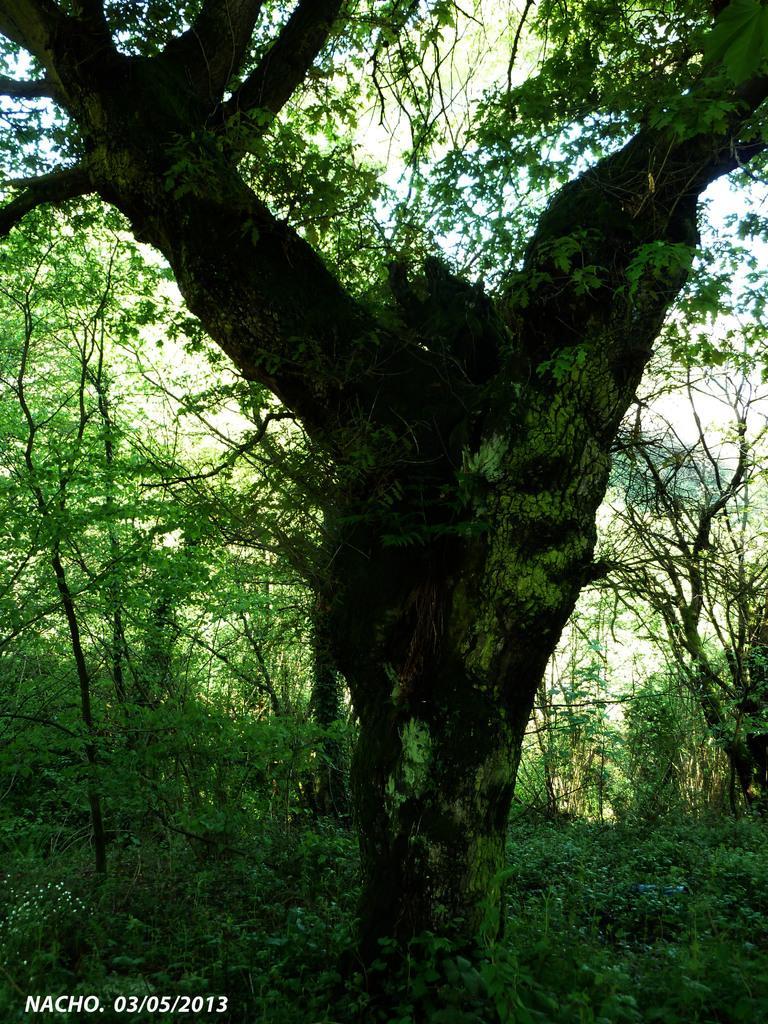How would you summarize this image in a sentence or two? As we can see in the image there is a tree, grass and plants. On the top there is a sky. 